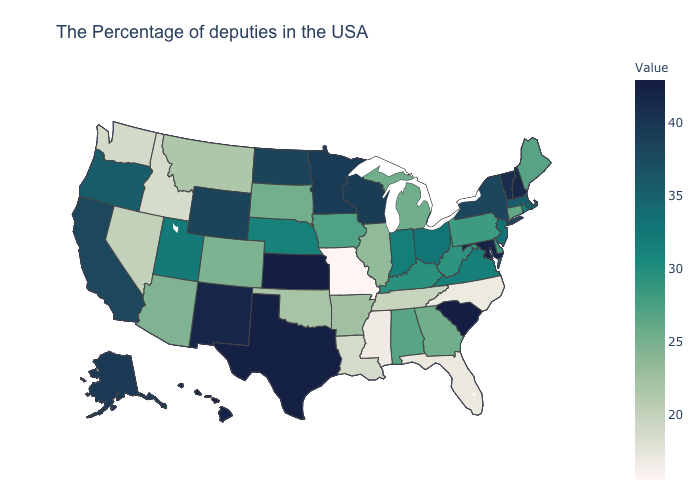Among the states that border Oregon , which have the highest value?
Keep it brief. California. Is the legend a continuous bar?
Be succinct. Yes. Among the states that border Nebraska , which have the highest value?
Concise answer only. Kansas. 